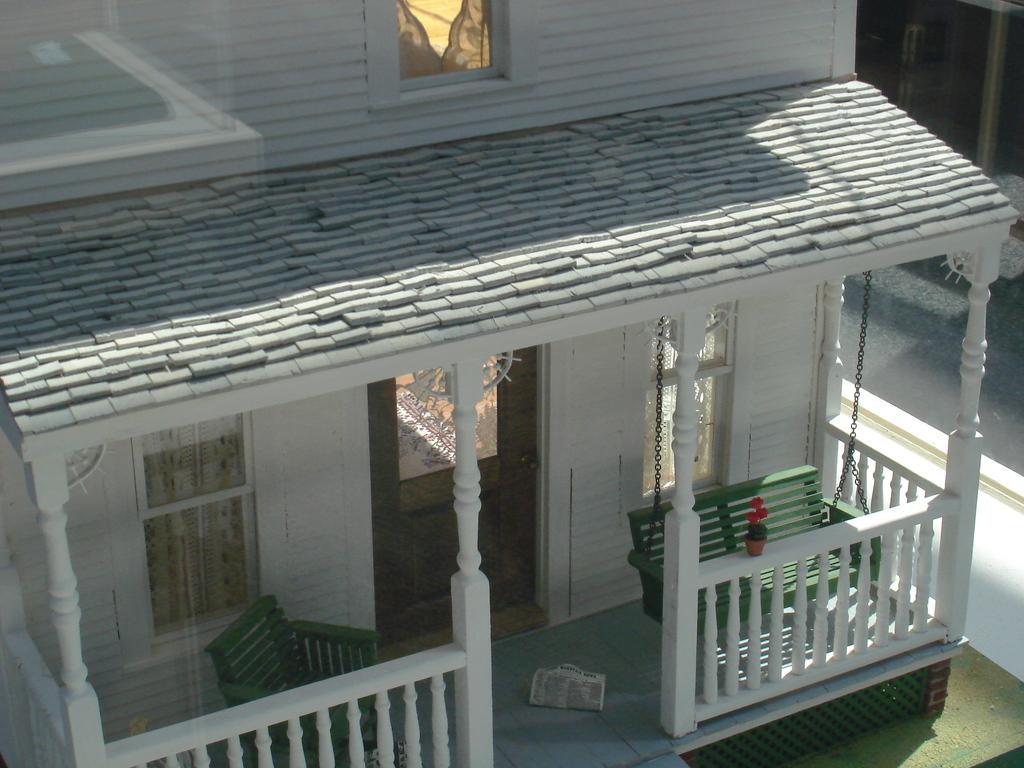Could you give a brief overview of what you see in this image? In this image we can see the porch of a building, on the porch there is a newspaper on the surface and there are two wooden chairs on the porch, there is a wooden door entrance into the building, beside the door there are two glass windows. 